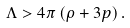Convert formula to latex. <formula><loc_0><loc_0><loc_500><loc_500>\Lambda > 4 \pi \left ( \rho + 3 p \right ) .</formula> 